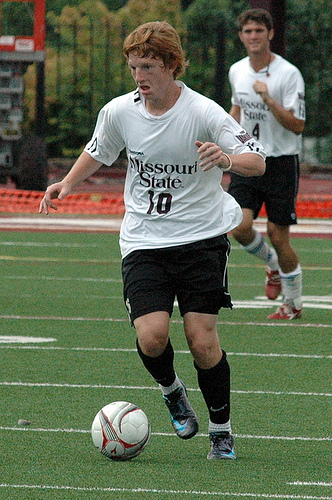<image>
Is there a ball to the right of the shoe? Yes. From this viewpoint, the ball is positioned to the right side relative to the shoe. 